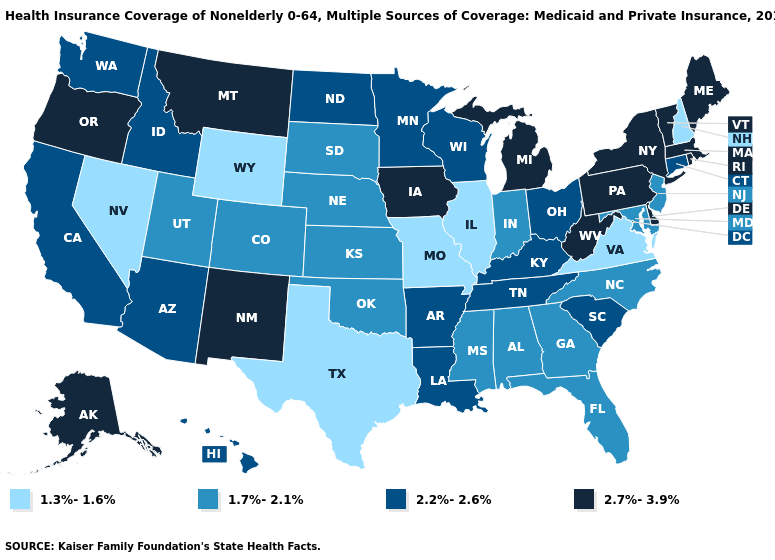What is the highest value in the MidWest ?
Give a very brief answer. 2.7%-3.9%. What is the value of Colorado?
Short answer required. 1.7%-2.1%. What is the lowest value in the USA?
Be succinct. 1.3%-1.6%. Which states hav the highest value in the Northeast?
Write a very short answer. Maine, Massachusetts, New York, Pennsylvania, Rhode Island, Vermont. Which states have the lowest value in the USA?
Be succinct. Illinois, Missouri, Nevada, New Hampshire, Texas, Virginia, Wyoming. Among the states that border Kentucky , does Tennessee have the lowest value?
Quick response, please. No. What is the lowest value in the South?
Be succinct. 1.3%-1.6%. Name the states that have a value in the range 2.2%-2.6%?
Short answer required. Arizona, Arkansas, California, Connecticut, Hawaii, Idaho, Kentucky, Louisiana, Minnesota, North Dakota, Ohio, South Carolina, Tennessee, Washington, Wisconsin. How many symbols are there in the legend?
Quick response, please. 4. How many symbols are there in the legend?
Answer briefly. 4. Does Virginia have the lowest value in the South?
Quick response, please. Yes. Does Minnesota have a higher value than Kansas?
Answer briefly. Yes. Is the legend a continuous bar?
Answer briefly. No. What is the value of Michigan?
Concise answer only. 2.7%-3.9%. Does the first symbol in the legend represent the smallest category?
Quick response, please. Yes. 